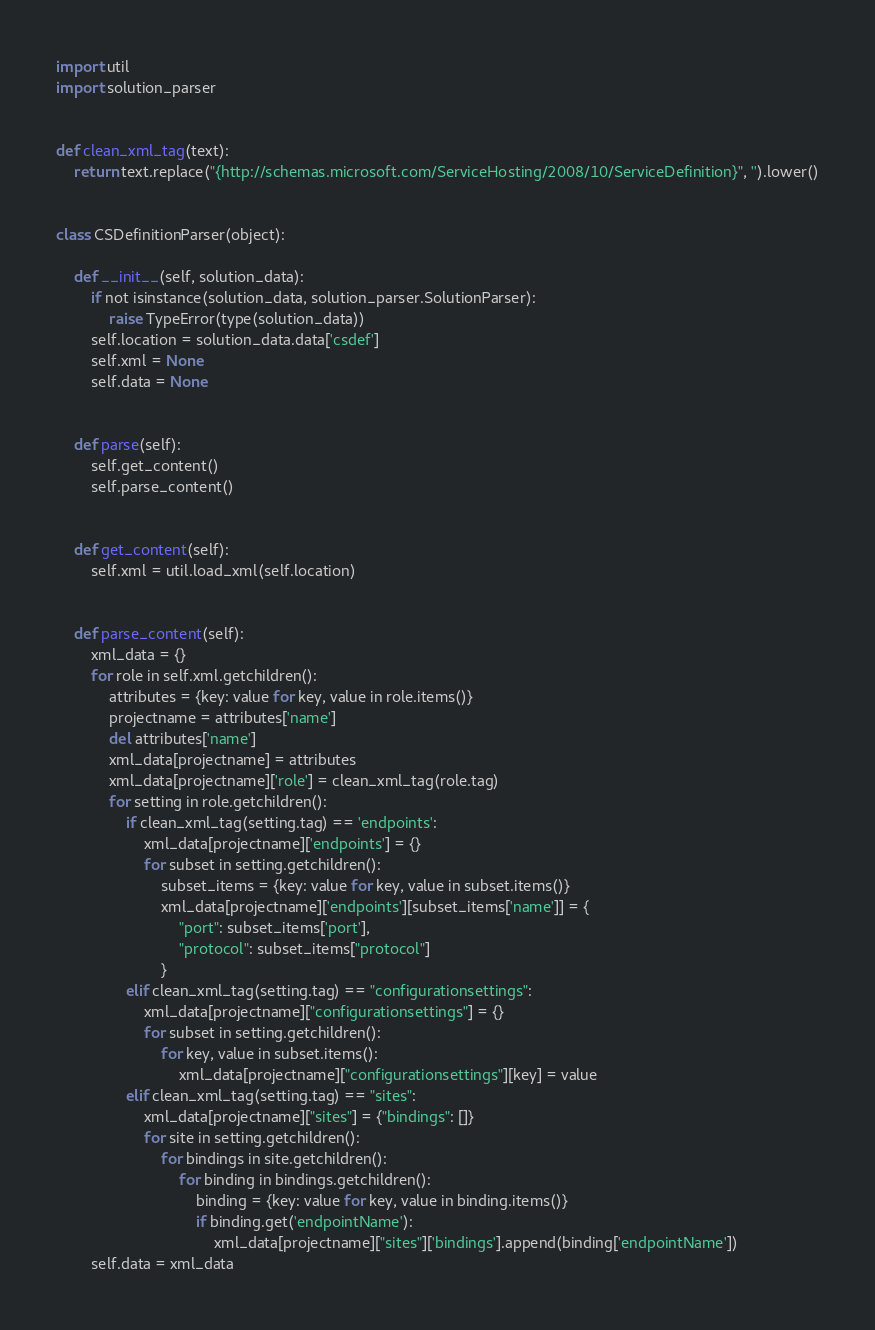<code> <loc_0><loc_0><loc_500><loc_500><_Python_>import util
import solution_parser


def clean_xml_tag(text):
    return text.replace("{http://schemas.microsoft.com/ServiceHosting/2008/10/ServiceDefinition}", '').lower()


class CSDefinitionParser(object):

    def __init__(self, solution_data):
        if not isinstance(solution_data, solution_parser.SolutionParser):
            raise TypeError(type(solution_data))
        self.location = solution_data.data['csdef']
        self.xml = None
        self.data = None


    def parse(self):
        self.get_content()
        self.parse_content()


    def get_content(self):
        self.xml = util.load_xml(self.location)


    def parse_content(self):
        xml_data = {}
        for role in self.xml.getchildren():
            attributes = {key: value for key, value in role.items()}
            projectname = attributes['name']
            del attributes['name']
            xml_data[projectname] = attributes
            xml_data[projectname]['role'] = clean_xml_tag(role.tag)
            for setting in role.getchildren():
                if clean_xml_tag(setting.tag) == 'endpoints':
                    xml_data[projectname]['endpoints'] = {}
                    for subset in setting.getchildren():
                        subset_items = {key: value for key, value in subset.items()}
                        xml_data[projectname]['endpoints'][subset_items['name']] = {
                            "port": subset_items['port'], 
                            "protocol": subset_items["protocol"]
                        }
                elif clean_xml_tag(setting.tag) == "configurationsettings":
                    xml_data[projectname]["configurationsettings"] = {}
                    for subset in setting.getchildren():
                        for key, value in subset.items():
                            xml_data[projectname]["configurationsettings"][key] = value
                elif clean_xml_tag(setting.tag) == "sites":
                    xml_data[projectname]["sites"] = {"bindings": []}
                    for site in setting.getchildren():
                        for bindings in site.getchildren():
                            for binding in bindings.getchildren():
                                binding = {key: value for key, value in binding.items()}
                                if binding.get('endpointName'):
                                    xml_data[projectname]["sites"]['bindings'].append(binding['endpointName'])
        self.data = xml_data
</code> 